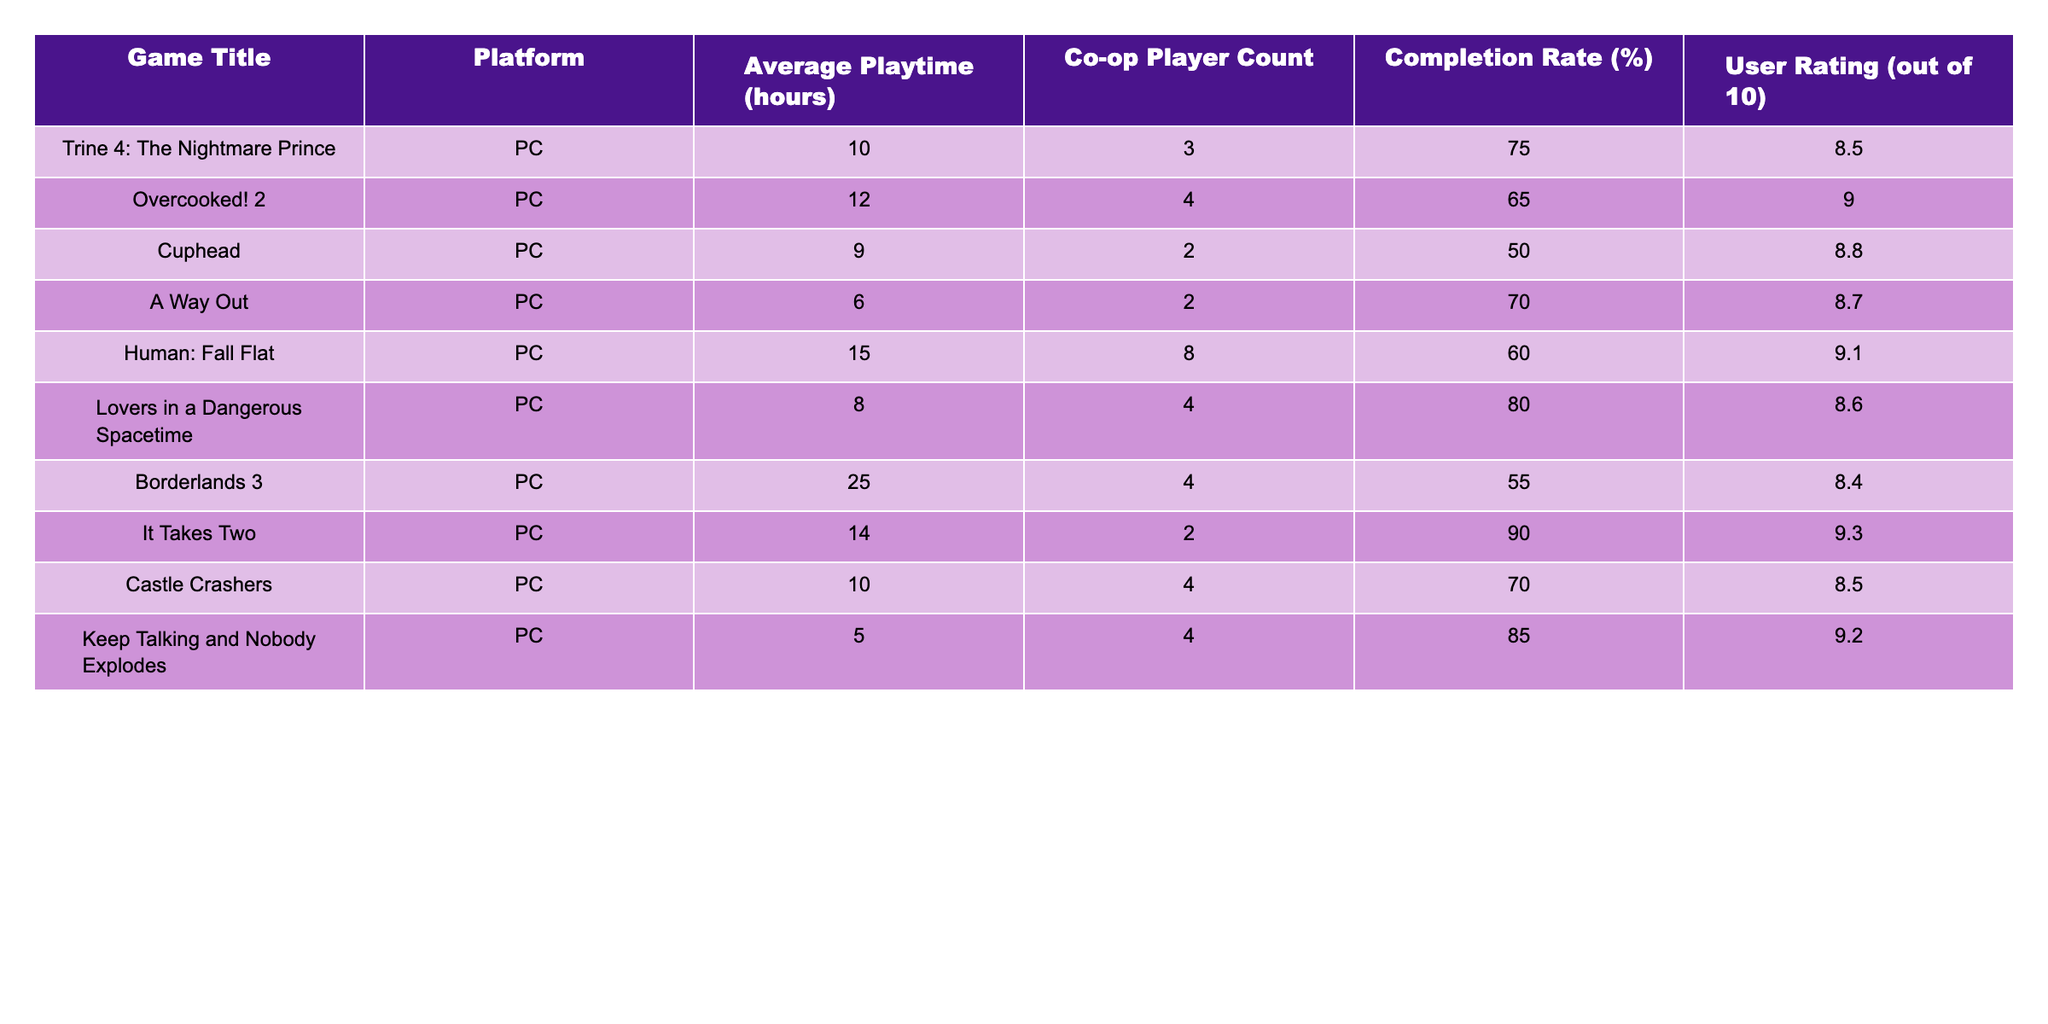What is the game with the highest average playtime? The table shows that Borderlands 3 has the highest average playtime at 25 hours.
Answer: Borderlands 3 Which game has the lowest completion rate? Among the listed games, Cuphead has the lowest completion rate at 50%.
Answer: Cuphead What is the average user rating for the games listed? To find the average user rating, sum all user ratings (8.5 + 9.0 + 8.8 + 8.7 + 9.1 + 8.6 + 8.4 + 9.3 + 8.5 + 9.2 = 88.6) and divide by the number of games (10). Thus, 88.6/10 = 8.86.
Answer: 8.86 Is the completion rate for It Takes Two greater than 85%? It Takes Two has a completion rate of 90%, which is greater than 85%.
Answer: Yes What is the combined average playtime of games with a co-op player count of 4? The games with a co-op player count of 4 are Overcooked! 2, Lovers in a Dangerous Spacetime, Borderlands 3, and Castle Crashers. Their average playtimes are 12, 8, 25, and 10 hours, respectively. Summing these gives 12 + 8 + 25 + 10 = 55 hours. Then divide by 4 to obtain the average: 55/4 = 13.75 hours.
Answer: 13.75 hours Which game has the highest rating and a completion rate below 75%? Checking the table, Cuphead has a rating of 8.8 and a completion rate of 50%, which is below 75%. It is the only game fitting this criterion.
Answer: Cuphead How many games have an average playtime of more than 10 hours? Looking at the average playtime column, 5 games have playtimes of more than 10 hours: Overcooked! 2, Human: Fall Flat, It Takes Two, and Borderlands 3.
Answer: 5 games What is the relationship between the average playtime and user rating of games in this table? To analyze the relationship, we can compare the average playtime and user ratings. Generally, a few games, like Overcooked! 2 and It Takes Two, show higher ratings with moderate playtime, while games with higher playtime, like Borderlands 3, have lower ratings. This suggests that increased playtime does not always correlate with better ratings.
Answer: There is no consistent relationship What is the completion rate difference between Human: Fall Flat and A Way Out? Human: Fall Flat has a completion rate of 60% and A Way Out has a completion rate of 70%. The difference between their completion rates is calculated as 70% - 60% = 10%.
Answer: 10% 